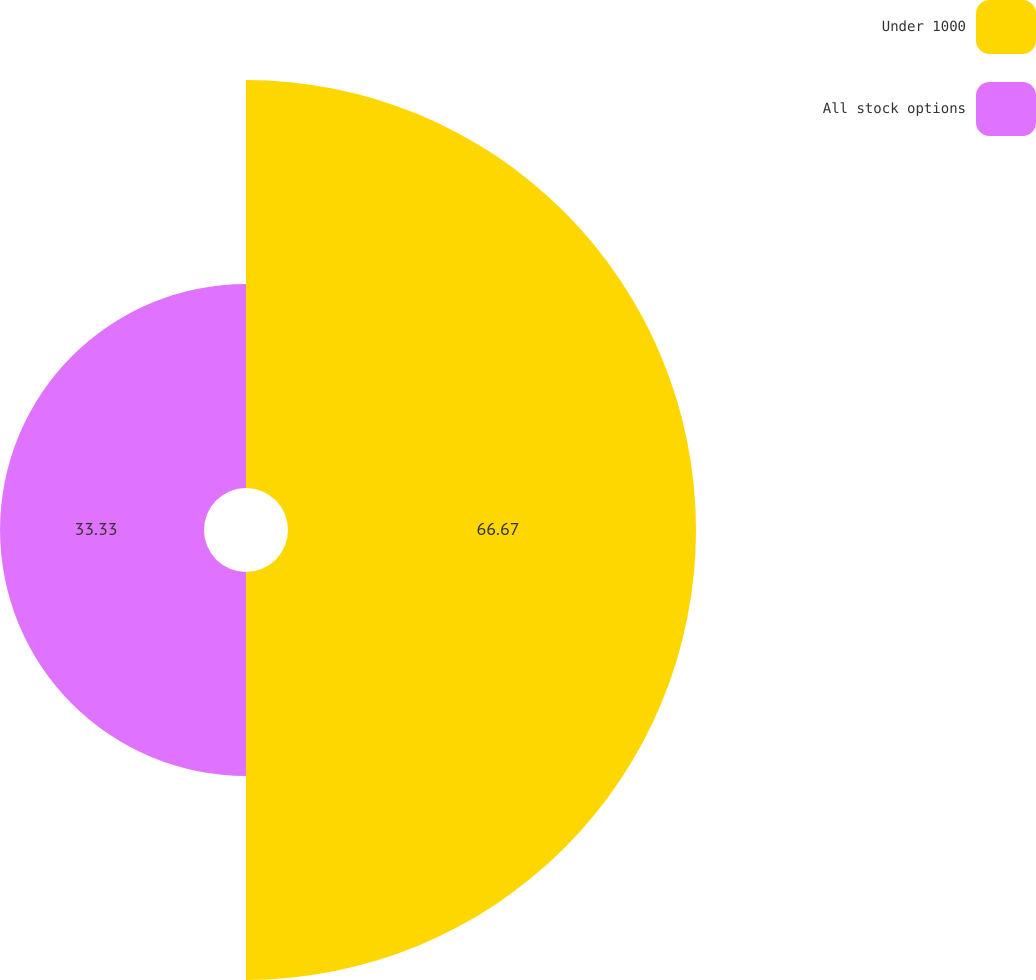Convert chart to OTSL. <chart><loc_0><loc_0><loc_500><loc_500><pie_chart><fcel>Under 1000<fcel>All stock options<nl><fcel>66.67%<fcel>33.33%<nl></chart> 